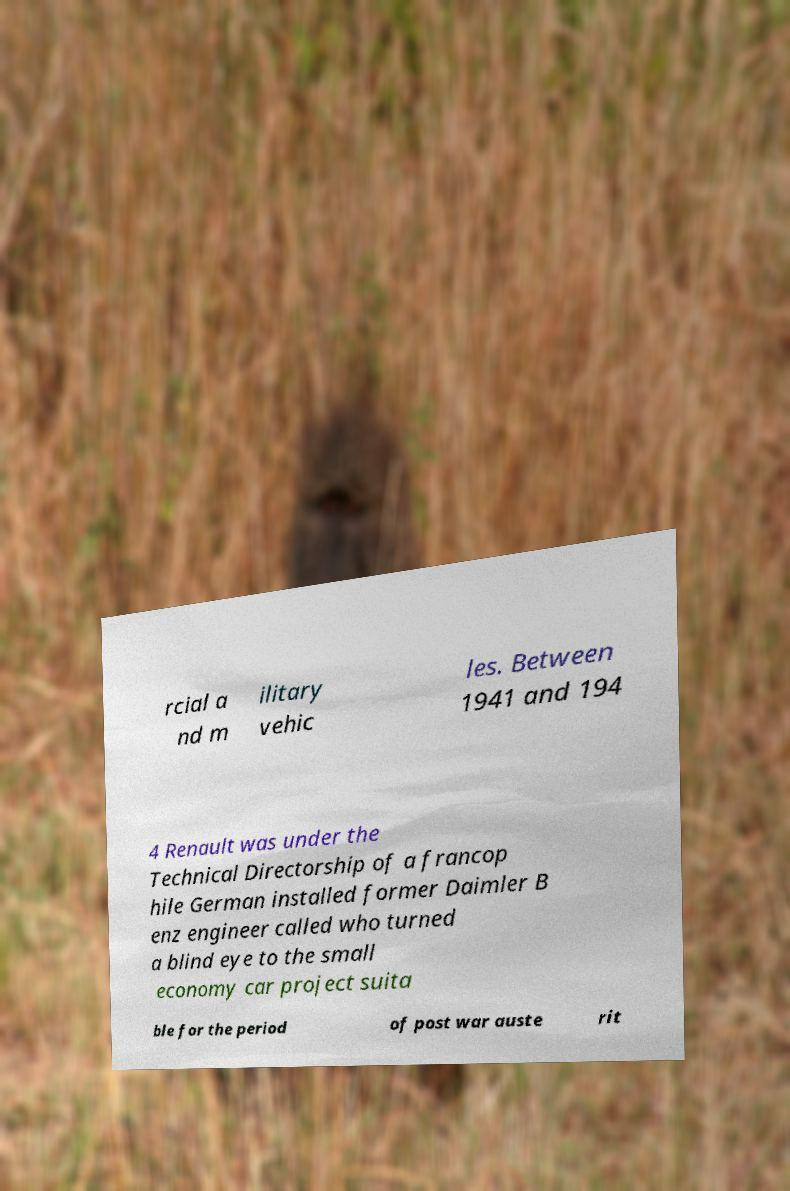Please read and relay the text visible in this image. What does it say? rcial a nd m ilitary vehic les. Between 1941 and 194 4 Renault was under the Technical Directorship of a francop hile German installed former Daimler B enz engineer called who turned a blind eye to the small economy car project suita ble for the period of post war auste rit 